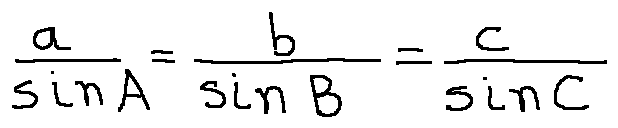Convert formula to latex. <formula><loc_0><loc_0><loc_500><loc_500>\frac { a } { \sin A } = \frac { b } { \sin B } = \frac { c } { \sin C }</formula> 